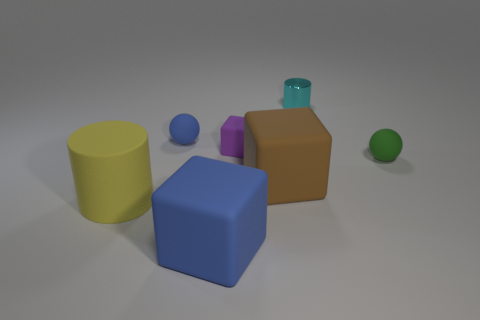Add 3 big cubes. How many objects exist? 10 Subtract all big blocks. How many blocks are left? 1 Subtract all balls. How many objects are left? 5 Subtract 3 cubes. How many cubes are left? 0 Subtract all red balls. Subtract all yellow cylinders. How many balls are left? 2 Subtract all purple balls. How many blue cubes are left? 1 Subtract all purple shiny cubes. Subtract all small purple matte things. How many objects are left? 6 Add 4 large blue rubber things. How many large blue rubber things are left? 5 Add 7 rubber cylinders. How many rubber cylinders exist? 8 Subtract all green balls. How many balls are left? 1 